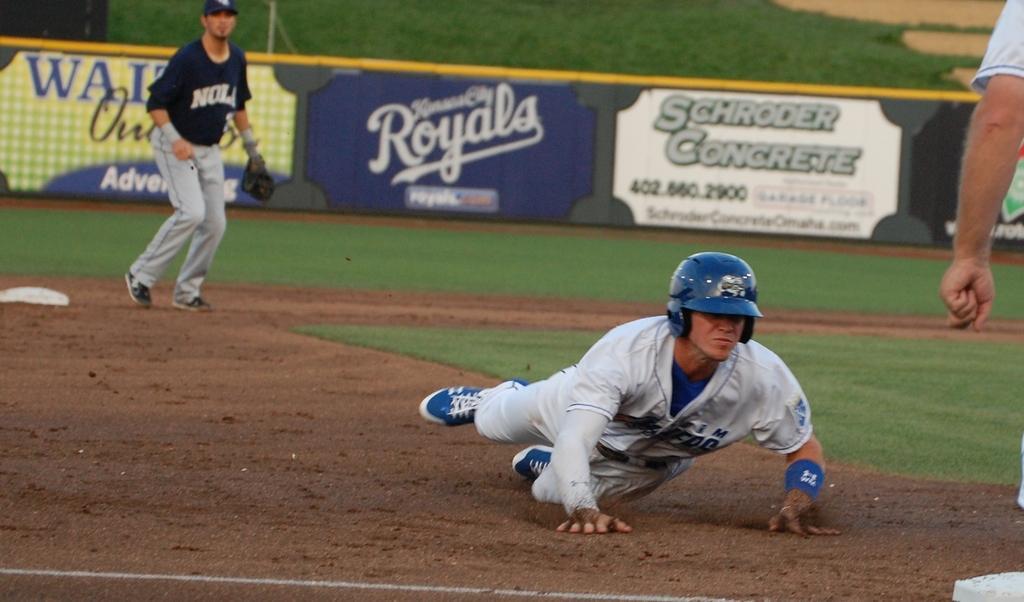Could you give a brief overview of what you see in this image? In this picture we can see people on the ground and in the background we can see an advertisement board, grass. 